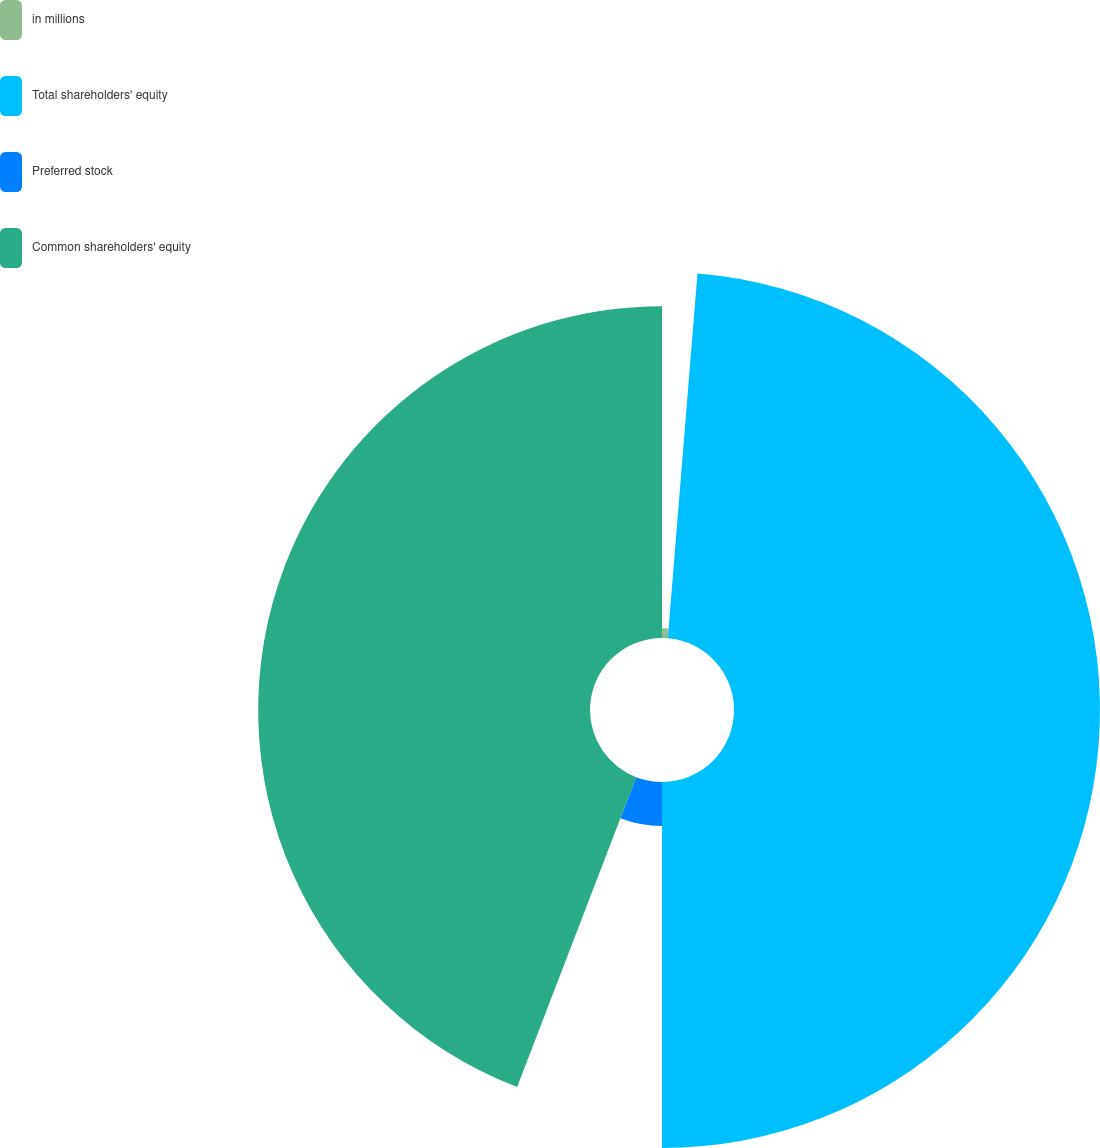<chart> <loc_0><loc_0><loc_500><loc_500><pie_chart><fcel>in millions<fcel>Total shareholders' equity<fcel>Preferred stock<fcel>Common shareholders' equity<nl><fcel>1.29%<fcel>48.71%<fcel>5.84%<fcel>44.16%<nl></chart> 